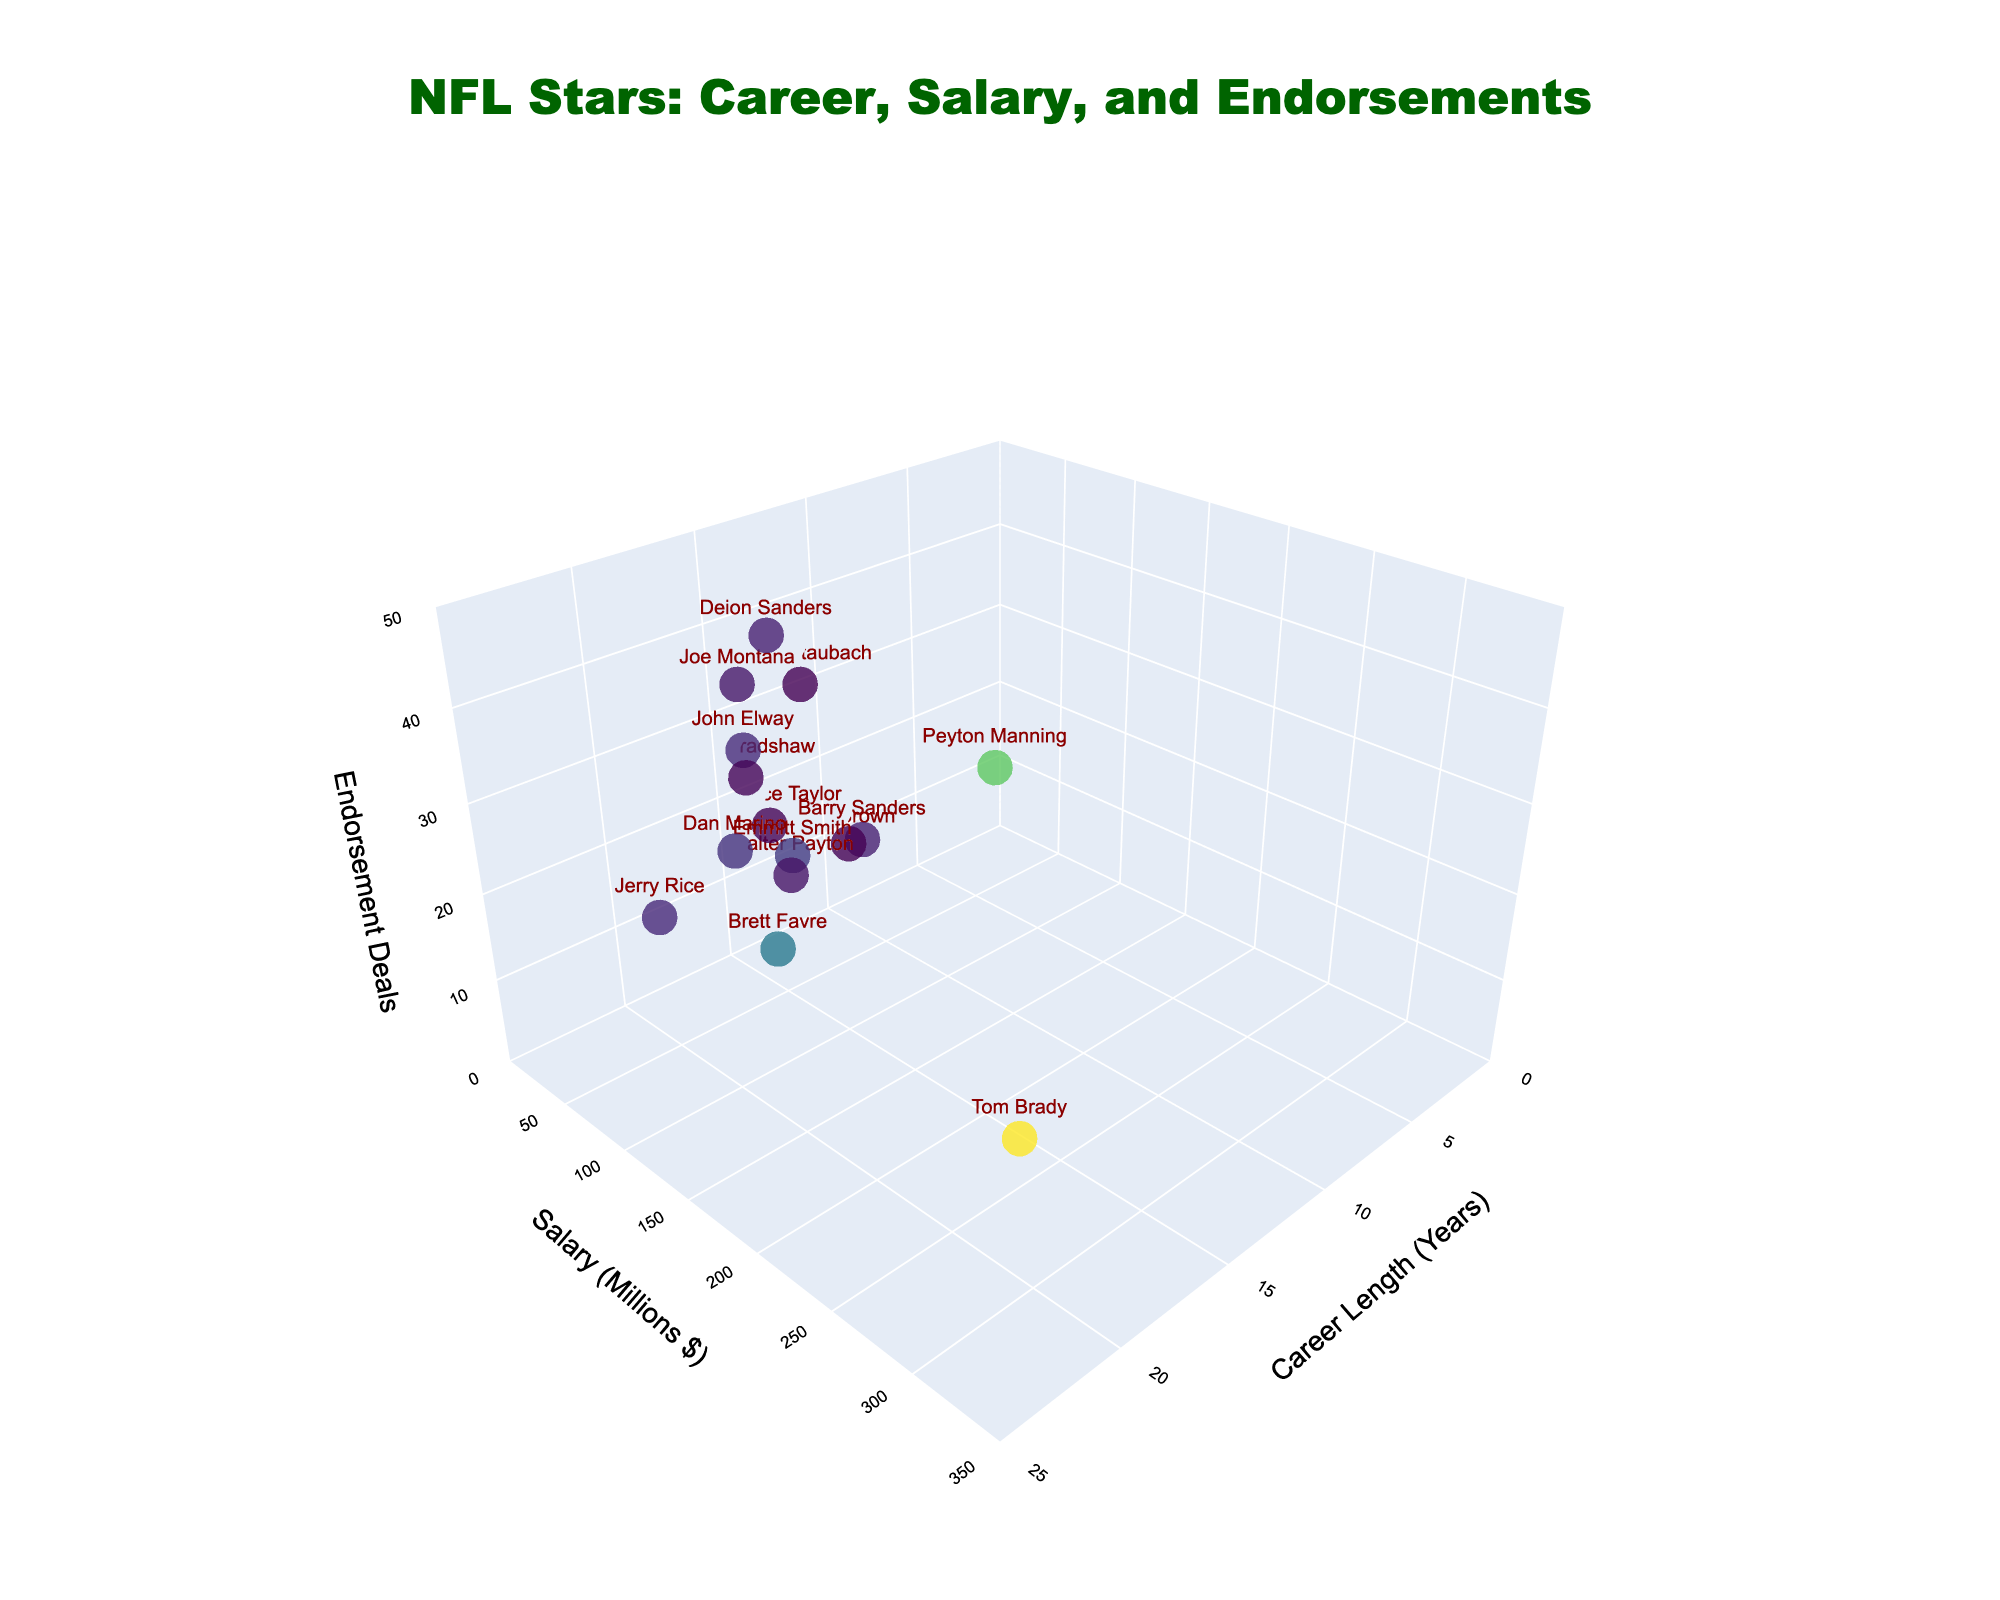What is the title of the figure? The title is located at the top center of the figure and is the largest text, making it very visible and easy to read.
Answer: NFL Stars: Career, Salary, and Endorsements Which player has the highest salary? By looking at the y-axis (Salary in Millions $) and identifying the highest point, the player's name labeled there is the answer.
Answer: Tom Brady How many players have a career length of more than 15 years? Count the number of data points situated beyond the 15-year mark on the x-axis.
Answer: 8 Which player had the least endorsement deals and what was their career length? Find the lowest point on the z-axis (Endorsement Deals) and read the player's name and their career length from the labels.
Answer: Jim Brown, 9 years Between John Elway and Joe Montana, who had more endorsement deals? Locate both players on the figure and compare their values on the z-axis (Endorsement Deals).
Answer: Joe Montana What is the total number of endorsement deals for players with a career length of less than 15 years? Sum the endorsement deals of players whose career lengths, noted on the x-axis, are below 15 years: Barry Sanders (12), Walter Payton (10), Terry Bradshaw (22), Roger Staubach (30), Jim Brown (8), Lawrence Taylor (15).
Answer: 97 Who has more endorsement deals, Peyton Manning or Deion Sanders? Locate both points and compare their respective values on the z-axis (Endorsement Deals).
Answer: Peyton Manning What is the average salary of players with a career lasting exactly 20 years? Identify the salary values for players with exactly 20 years (Jerry Rice, Brett Favre) and calculate their average: (42 + 137) / 2.
Answer: 89.5 million dollars Between Joe Montana and Terry Bradshaw, who earned more in salary? Locate both players on the figure and compare their y-axis values (Salary in Millions $).
Answer: Joe Montana What is the range of career lengths represented in the figure? Identify the minimum and maximum values on the x-axis and determine the range: minimum is 9 (Jim Brown) and maximum is 23 (Tom Brady).
Answer: 9 to 23 years 